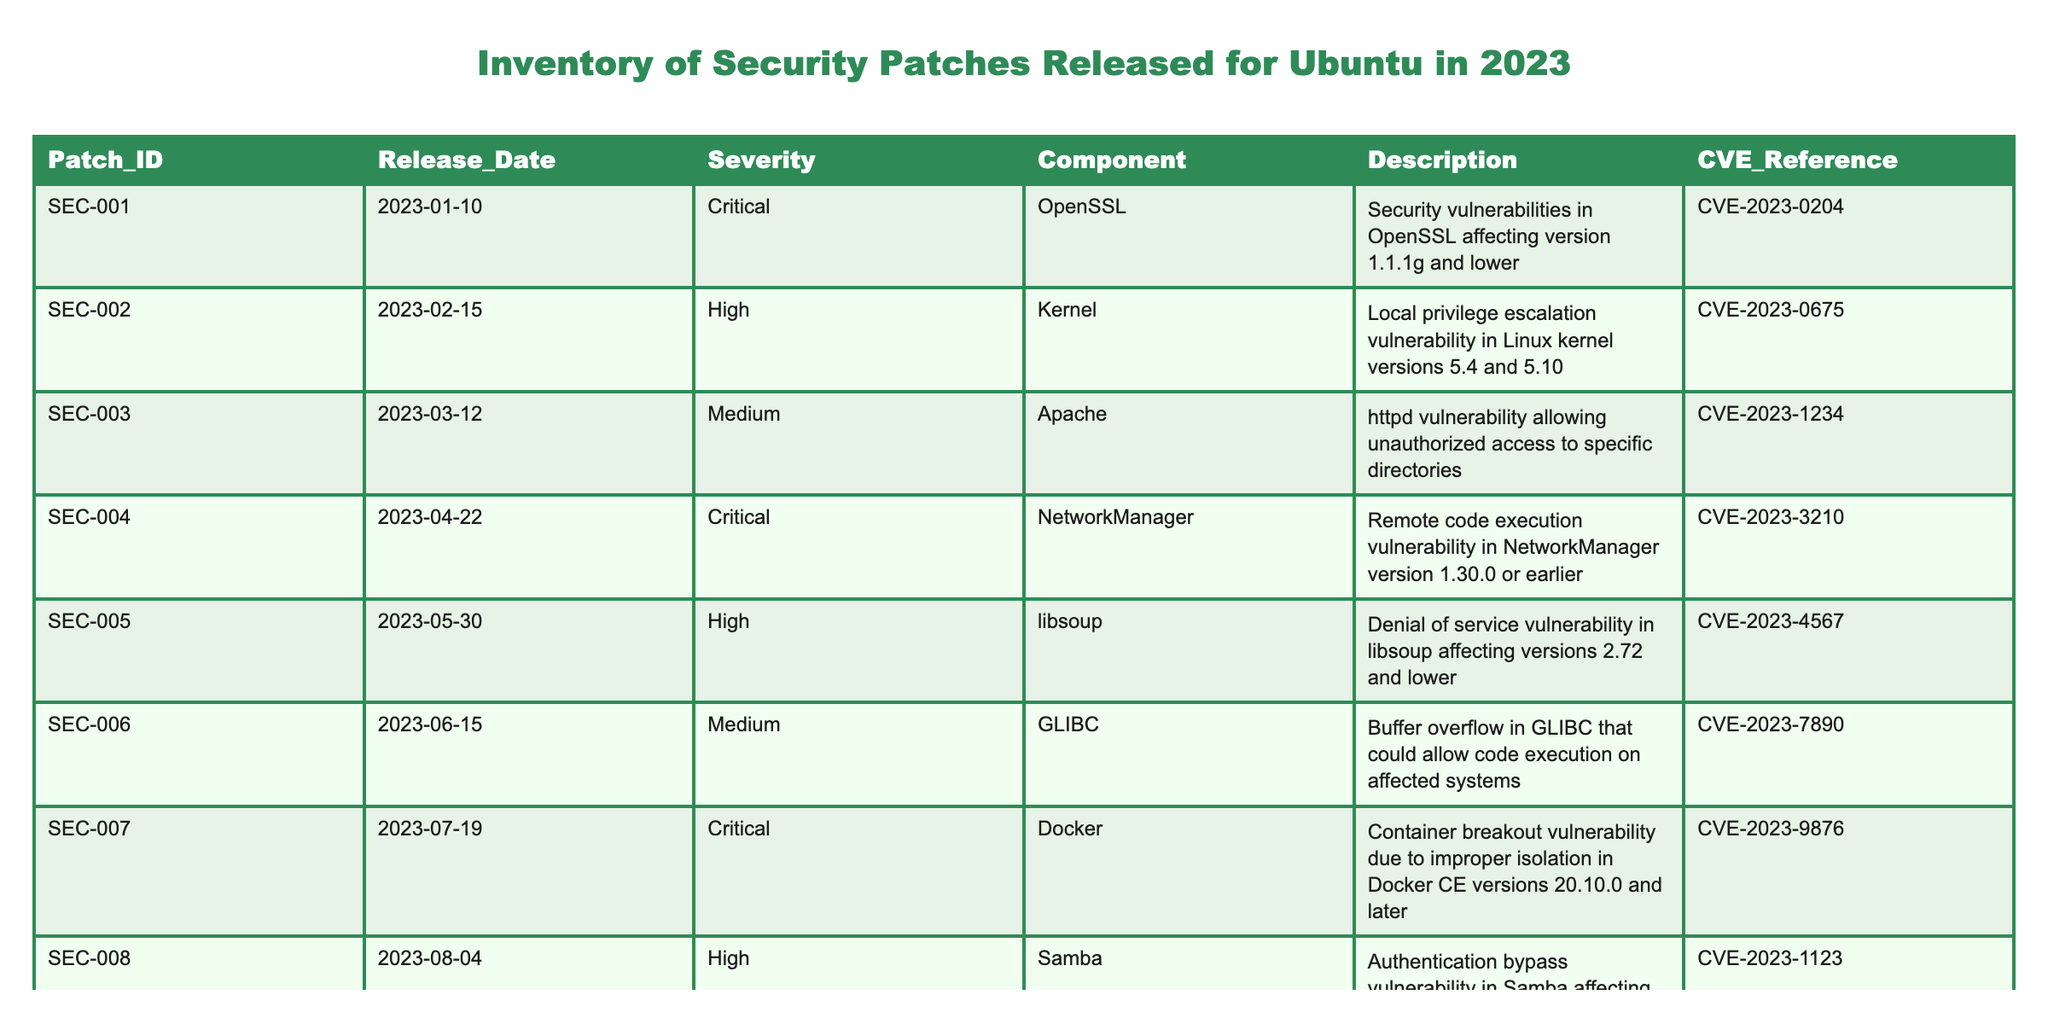What is the release date of the highest severity patch? The highest severity patch is identified with the severity level "Critical." In the table, there are three patches with this severity: SEC-001, SEC-004, and SEC-007. The release dates for these patches are 2023-01-10, 2023-04-22, and 2023-07-19, respectively. The earliest release date among them is 2023-01-10, which corresponds to SEC-001.
Answer: 2023-01-10 How many patches were released in the first half of 2023? The first half of 2023 includes the months from January to June. By reviewing the release dates in the table, we see that SEC-001 (January), SEC-002 (February), SEC-003 (March), SEC-004 (April), SEC-005 (May), and SEC-006 (June) are all released within this range. This gives a total of six patches.
Answer: 6 Is there any patch that does not reference a CVE? Each row in the table contains a CVE_Reference value associated with the patches. Upon examining all the rows and their corresponding CVE references, every patch listed in the table has an associated CVE reference. Thus, there are no patches without a CVE reference.
Answer: No What is the total number of patches that have a severity of either Critical or High? Patches categorized as Critical or High are SEC-001, SEC-002, SEC-004, SEC-005, SEC-007, SEC-008, and SEC-010. Counting these patches, we have seven patches in total.
Answer: 7 Which component had the most vulnerabilities listed in the provided patches? Analyzing the components of the patches, we find OpenSSL (1), Kernel (1), Apache (1), NetworkManager (1), libsoup (1), GLIBC (1), Docker (1), Samba (1), and Xen (1). Each component has only one associated vulnerability, meaning no single component has more than another. Therefore, all components have equal vulnerabilities regarding the patches listed in the table.
Answer: All components are equal 